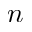<formula> <loc_0><loc_0><loc_500><loc_500>n</formula> 